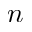<formula> <loc_0><loc_0><loc_500><loc_500>n</formula> 